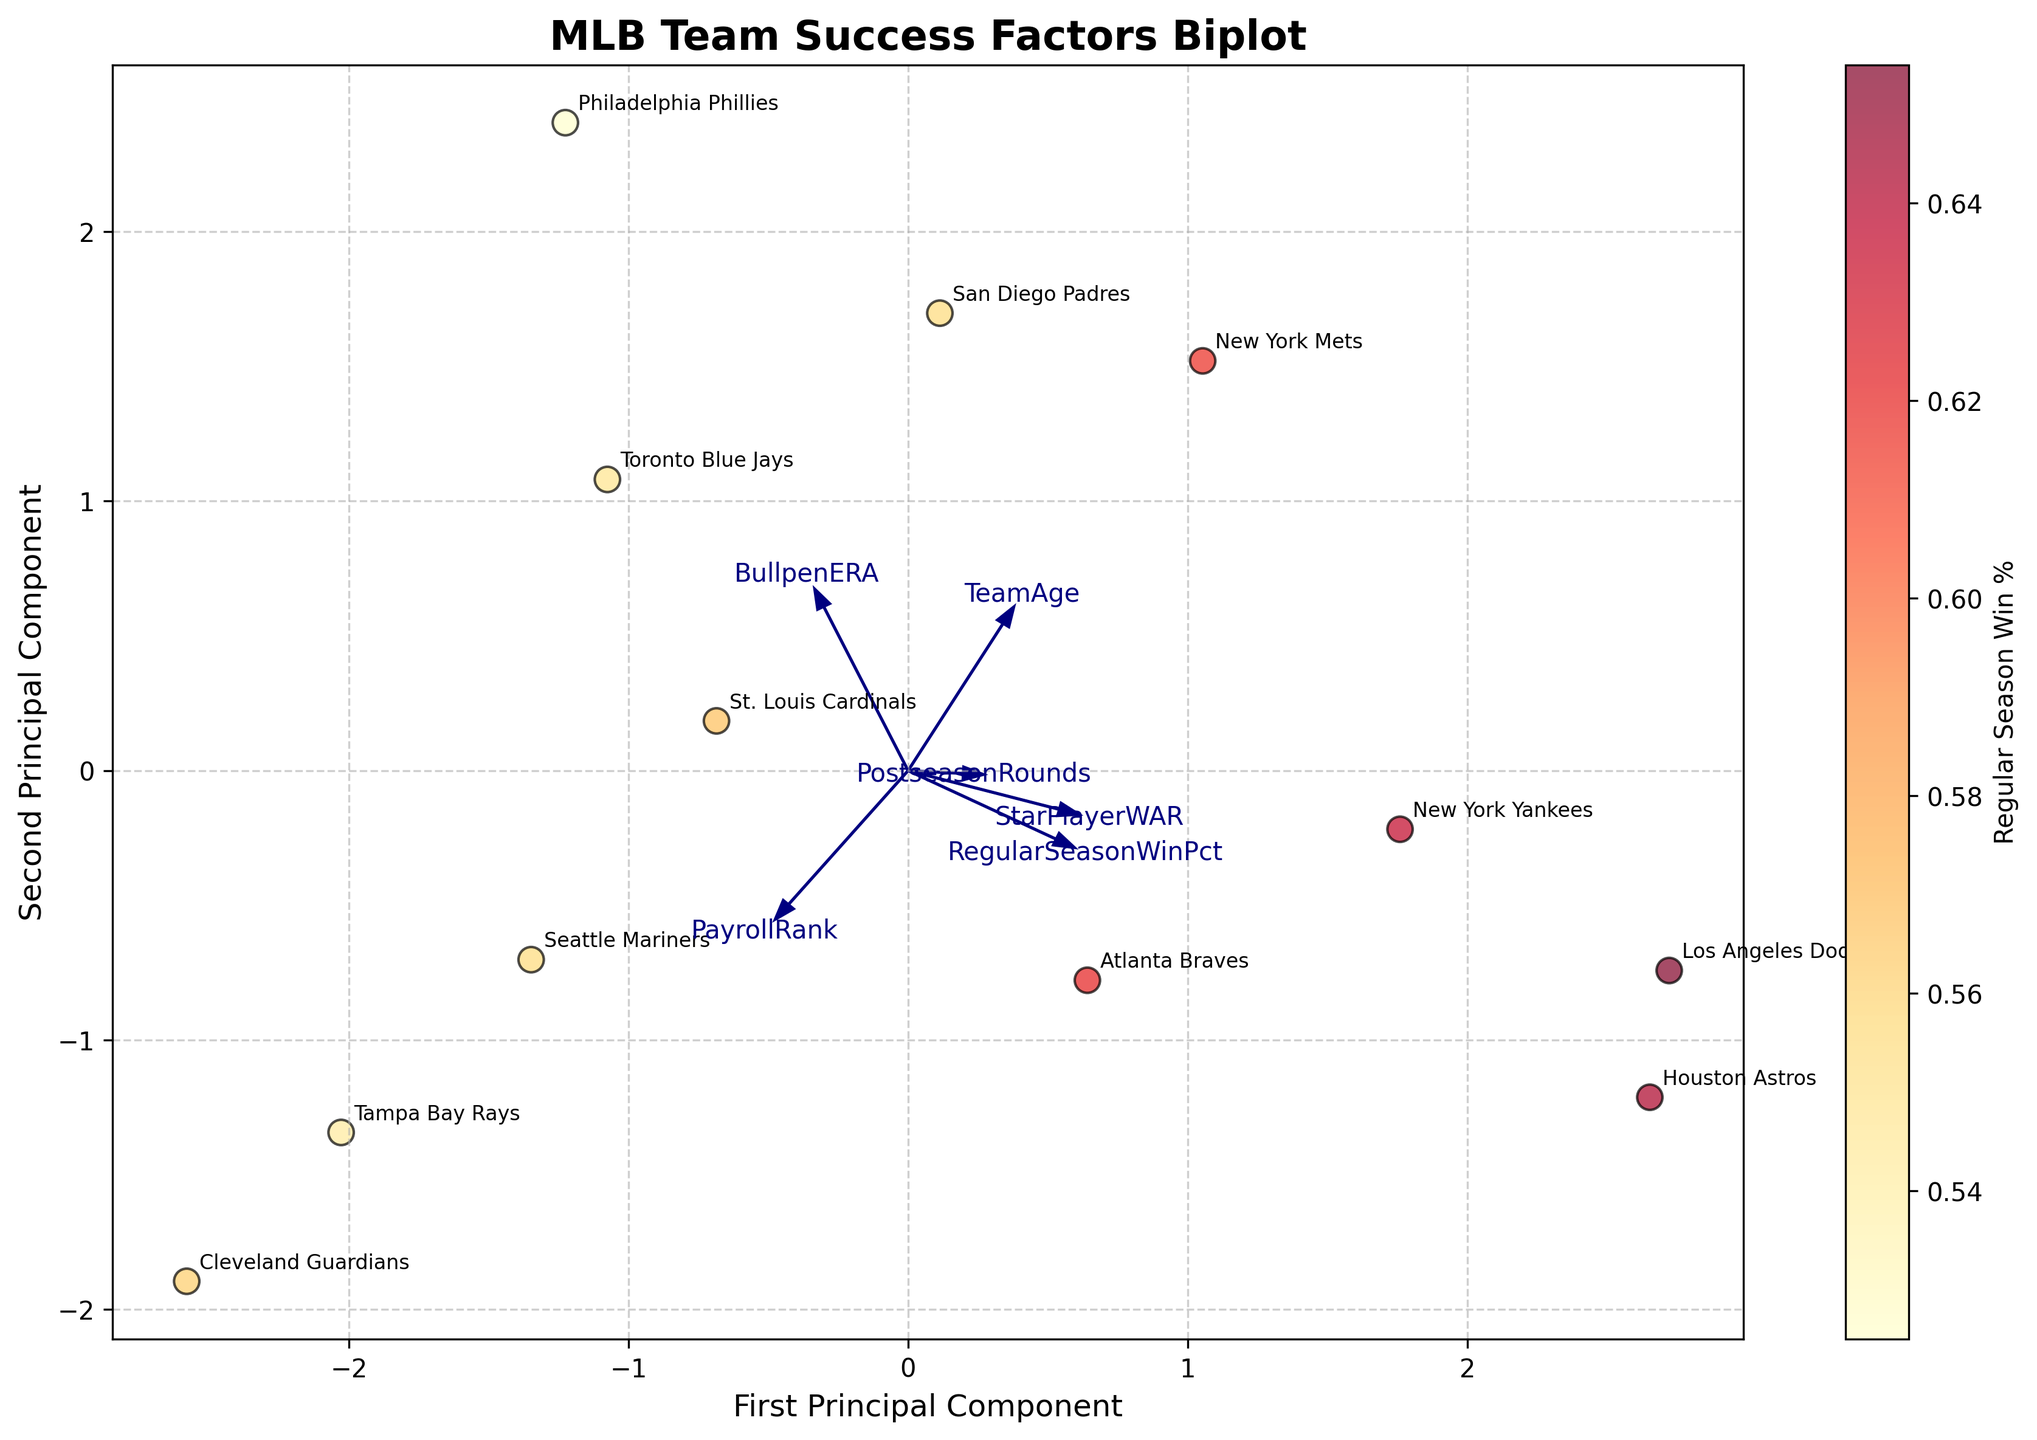What's the title of the figure? The title is displayed prominently at the top of the figure in a bold, larger font.
Answer: MLB Team Success Factors Biplot What's the color of the scatter points on the plot? The scatter points appear in a gradient from yellow to red, representing varying regular season win percentages, with a black edge color.
Answer: Yellow to red gradient with black edges How many MLB teams are represented in the plot? Each data point corresponds to a unique team, and each team's name is annotated next to its data point. Counting these annotations gives the total number of teams.
Answer: 12 Which team is indicated by the most rightward scatter point? The team name annotation closest to the rightmost scatter point identifies the team.
Answer: Los Angeles Dodgers Which feature vector has the largest arrow in the biplot? By comparing the lengths of the arrows emanating from the origin, the feature with the longest arrow can be identified.
Answer: RegularSeasonWinPct What is the relationship between PayrollRank and PostseasonRounds based on the biplot arrows? The angle between the arrows for PayrollRank and PostseasonRounds is examined. A smaller angle indicates a positive correlation, a 90-degree angle suggests no correlation, and a larger angle indicates a negative correlation. The arrows for PayrollRank and PostseasonRounds form an obtuse angle, indicating a negative correlation.
Answer: Negative correlation Which teams have the highest and lowest Regular Season Win Percentages, and how are they positioned relative to each other? The color of the scatter points is examined to determine the win percentages, with red indicating a high win percentage and yellow indicating a low win percentage. The position of these points on the plot is then checked. The Houston Astros have one of the most red-shaded points (highest win percentage), while the Philadelphia Phillies have a lighter shade (lowest win percentage).
Answer: Highest: Houston Astros, Lowest: Philadelphia Phillies How are the features 'StarPlayerWAR' and 'TeamAge' correlated according to the plot? The feature vectors for 'StarPlayerWAR' and 'TeamAge' can be observed. The angle between these two arrows indicates their correlation; a smaller angle indicates a stronger positive correlation, a larger angle (approaching 180 degrees) indicates a stronger negative correlation. The arrows for 'StarPlayerWAR' and 'TeamAge' form an acute angle, indicating a positive correlation.
Answer: Positive correlation Which team has the highest BullpenERA, and how can this be seen on the plot? The 'BullpenERA' vector direction is followed to find the data points projecting furthest along this vector. The annotation next to the furthest point identifies the team with the highest BullpenERA.
Answer: Philadelphia Phillies What can be inferred about the 'RegularSeasonWinPct' based on its arrow direction and team positioning in the plot? Teams positioned along the 'RegularSeasonWinPct' arrow direction closer to the arrow tip generally have higher win percentages. Moreover, the regular season win percentage arrow also extends positively along the first principal component, which means it heavily contributes to differentiating teams' performances.
Answer: Teams further along the arrow have higher win percentages 